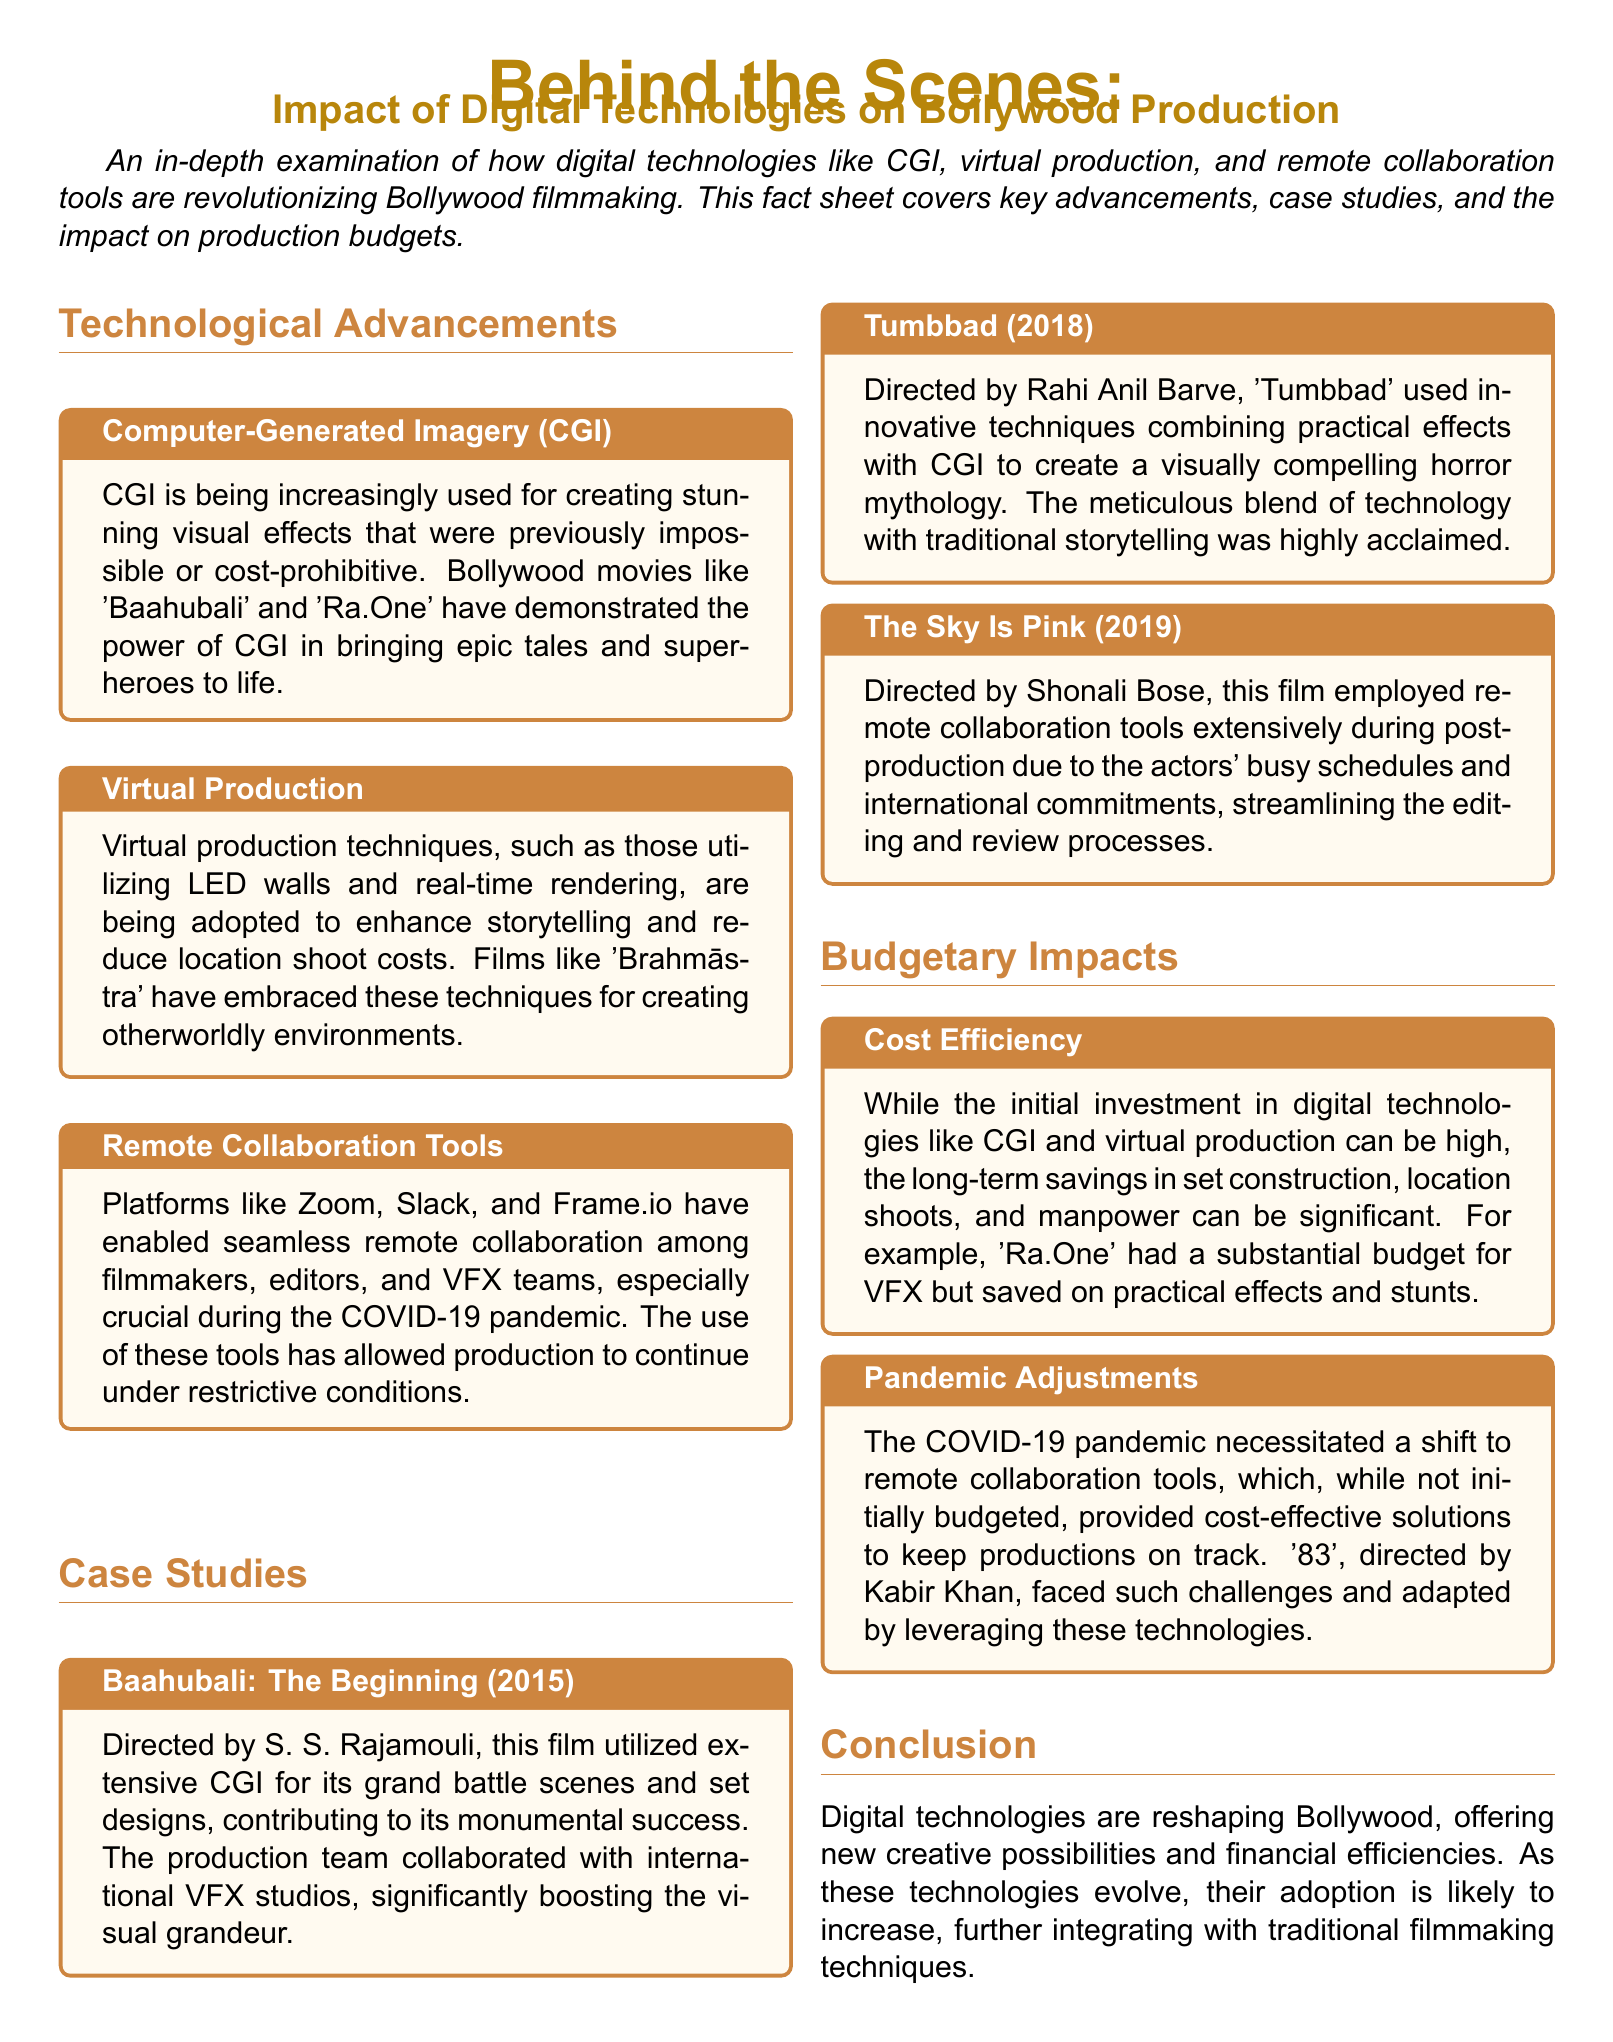What is the key technology used in 'Baahubali' for visual effects? The key technology used in 'Baahubali' for visual effects is CGI.
Answer: CGI Which film utilized virtual production techniques like LED walls? The film that utilized virtual production techniques like LED walls is 'Brahmāstra'.
Answer: Brahmāstra What year was 'Tumbbad' released? 'Tumbbad' was released in 2018.
Answer: 2018 What major adaptation did '83' make during the COVID-19 pandemic? '83' adapted by leveraging remote collaboration tools during the pandemic.
Answer: Remote collaboration tools What is one noted impact of digital technologies on production budgets? One noted impact of digital technologies on production budgets is cost efficiency.
Answer: Cost efficiency Why were remote collaboration tools significant during the pandemic? Remote collaboration tools were significant during the pandemic because they allowed production to continue under restrictive conditions.
Answer: Allowed production to continue Which director worked on 'The Sky Is Pink'? The director of 'The Sky Is Pink' is Shonali Bose.
Answer: Shonali Bose What was a critical component in the success of 'Baahubali'? A critical component in the success of 'Baahubali' was extensive CGI.
Answer: Extensive CGI 